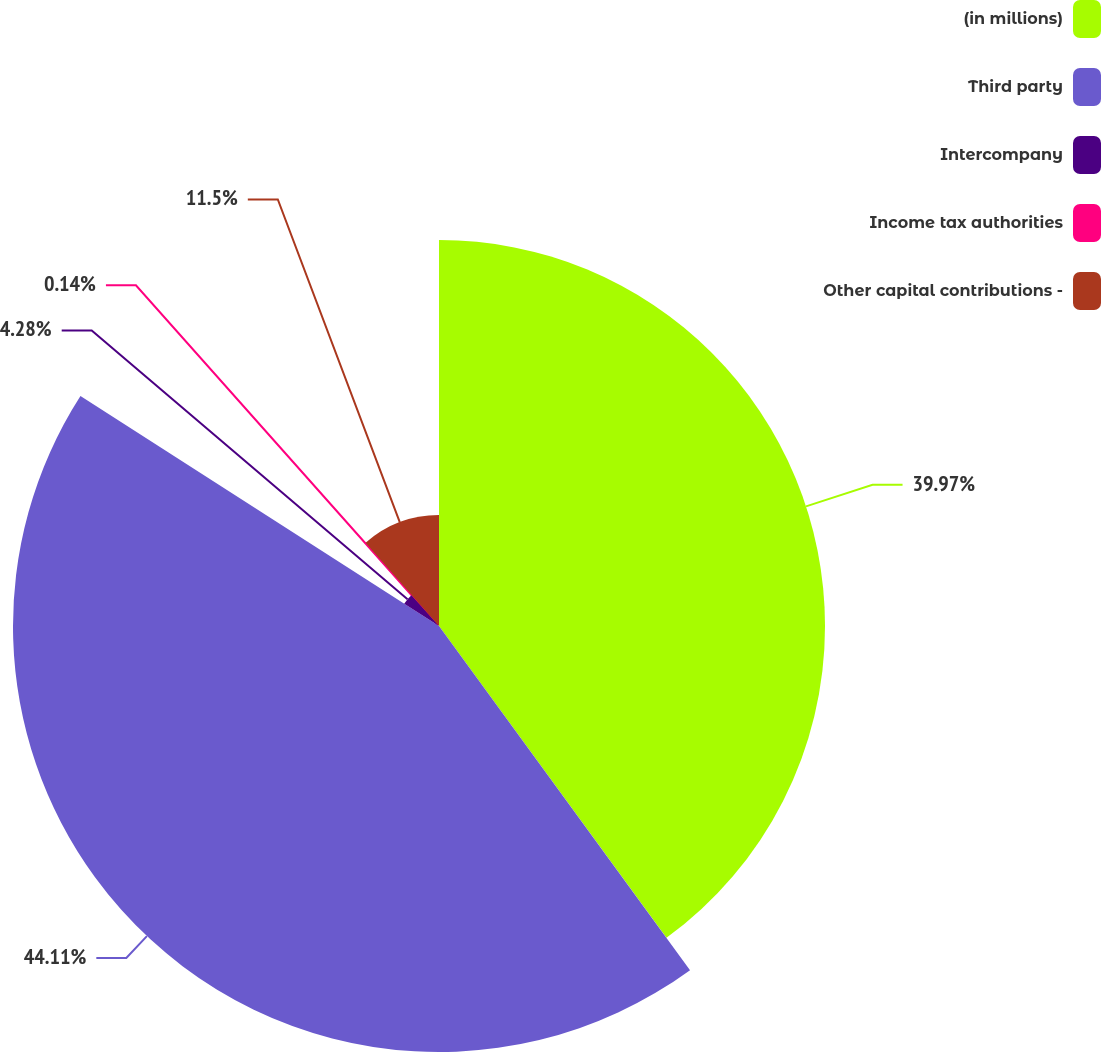Convert chart. <chart><loc_0><loc_0><loc_500><loc_500><pie_chart><fcel>(in millions)<fcel>Third party<fcel>Intercompany<fcel>Income tax authorities<fcel>Other capital contributions -<nl><fcel>39.97%<fcel>44.11%<fcel>4.28%<fcel>0.14%<fcel>11.5%<nl></chart> 